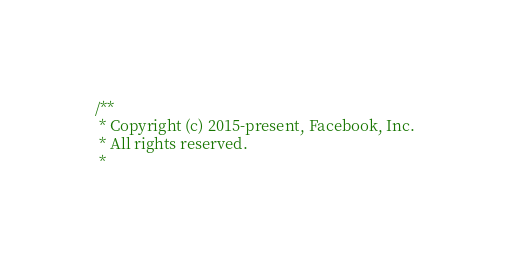<code> <loc_0><loc_0><loc_500><loc_500><_C_>/**
 * Copyright (c) 2015-present, Facebook, Inc.
 * All rights reserved.
 *</code> 